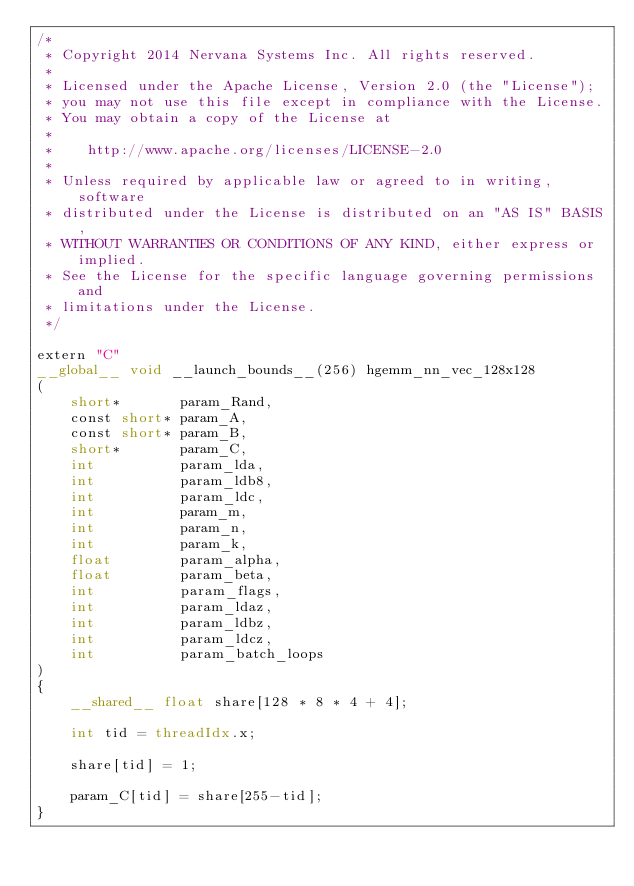Convert code to text. <code><loc_0><loc_0><loc_500><loc_500><_Cuda_>/*
 * Copyright 2014 Nervana Systems Inc. All rights reserved.
 *
 * Licensed under the Apache License, Version 2.0 (the "License");
 * you may not use this file except in compliance with the License.
 * You may obtain a copy of the License at
 * 
 *    http://www.apache.org/licenses/LICENSE-2.0
 * 
 * Unless required by applicable law or agreed to in writing, software
 * distributed under the License is distributed on an "AS IS" BASIS,
 * WITHOUT WARRANTIES OR CONDITIONS OF ANY KIND, either express or implied.
 * See the License for the specific language governing permissions and
 * limitations under the License.
 */

extern "C"
__global__ void __launch_bounds__(256) hgemm_nn_vec_128x128
(
    short*       param_Rand,
    const short* param_A,
    const short* param_B,
    short*       param_C,
    int          param_lda,  
    int          param_ldb8,  
    int          param_ldc,
    int          param_m,
    int          param_n,
    int          param_k,
    float        param_alpha,
    float        param_beta,
    int          param_flags,
    int          param_ldaz,
    int          param_ldbz,
    int          param_ldcz,
    int          param_batch_loops
)
{
    __shared__ float share[128 * 8 * 4 + 4];

    int tid = threadIdx.x;

    share[tid] = 1;

    param_C[tid] = share[255-tid];
}
</code> 